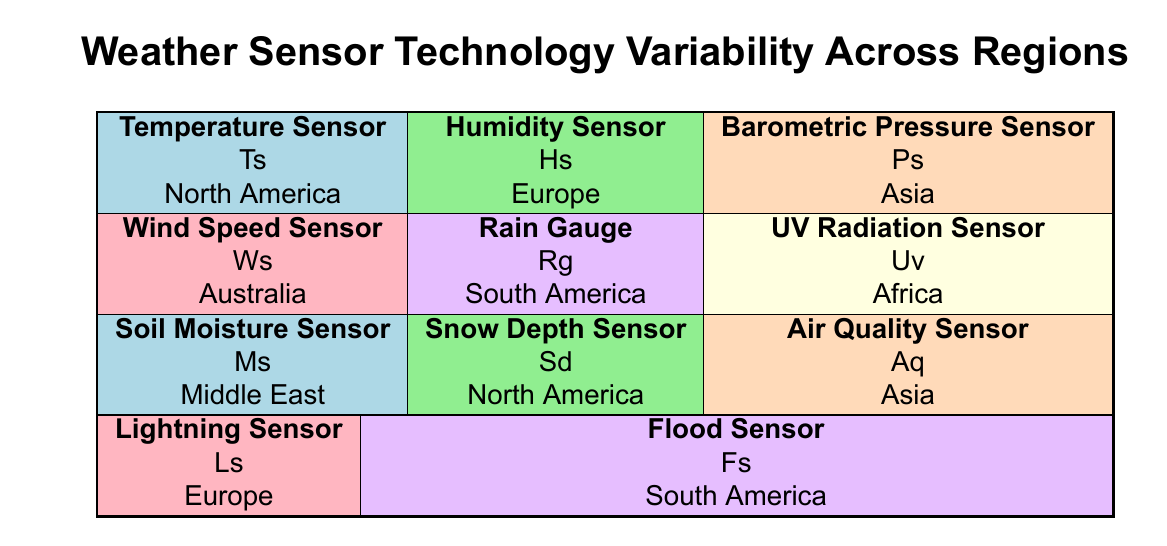What technology is used for barometric pressure sensing in Asia? The table lists the "Technology" for the "Barometric Pressure Sensor" under the "Asia" region, which is "MEMS Barometers."
Answer: MEMS Barometers Which region utilizes drone-mounted temperature sensors for wildlife tracking? According to the table, the "Temperature Sensor" in "North America" mentions it is used as "Drone-mounted for wildlife tracking."
Answer: North America What is the accuracy of the humidity sensor used in Europe? The table shows that the "Humidity Sensor" in "Europe" is "Capacitive Humidity Sensors" with an accuracy of "±2%."
Answer: ±2% Is the UV radiation sensor application environmental monitoring? The table indicates that the "UV Radiation Sensor" in Africa is used for "Environmental monitoring and health assessments," which confirms that it includes environmental monitoring.
Answer: Yes What type of sensor has the highest accuracy across the regions listed? To find the sensor with the highest accuracy, I will compare the accuracy rates from all sensors. The "Barometric Pressure Sensor" in Asia has an accuracy of "±0.1 hPa," which is the highest among the listed sensors.
Answer: ±0.1 hPa Which sensor is used for flood monitoring in South America, and what is its accuracy? I will look at the "Flood Sensor" in the "South America" section, which is described as "Ultrasonic Distance Sensors" with an accuracy of "±5 mm."
Answer: Ultrasonic Distance Sensors, ±5 mm How many types of sensors listed are used for agricultural purposes? From the table, the "Humidity Sensor" in Europe is for agriculture, and the "Rain Gauge" in South America also states application for agricultural planning. Thus, there are two sensors for agricultural purposes.
Answer: 2 What is the technology used for wind speed sensing in Australia? The table indicates that the "Wind Speed Sensor" in "Australia" employs "Anemometers (Mechanical and Ultrasonic)," which refers to the specifics of its technology.
Answer: Anemometers (Mechanical and Ultrasonic) Which sensor has the largest accuracy variation and what is that variation? The "Air Quality Sensor" in Asia is noted as having an accuracy of "±10%," which is the largest variation compared to the other sensors listed.
Answer: ±10% 